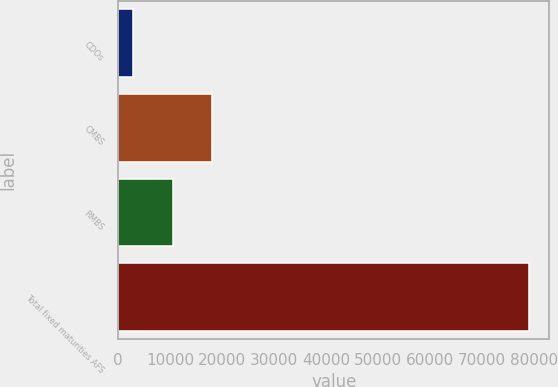Convert chart to OTSL. <chart><loc_0><loc_0><loc_500><loc_500><bar_chart><fcel>CDOs<fcel>CMBS<fcel>RMBS<fcel>Total fixed maturities AFS<nl><fcel>2819<fcel>18050.8<fcel>10434.9<fcel>78978<nl></chart> 